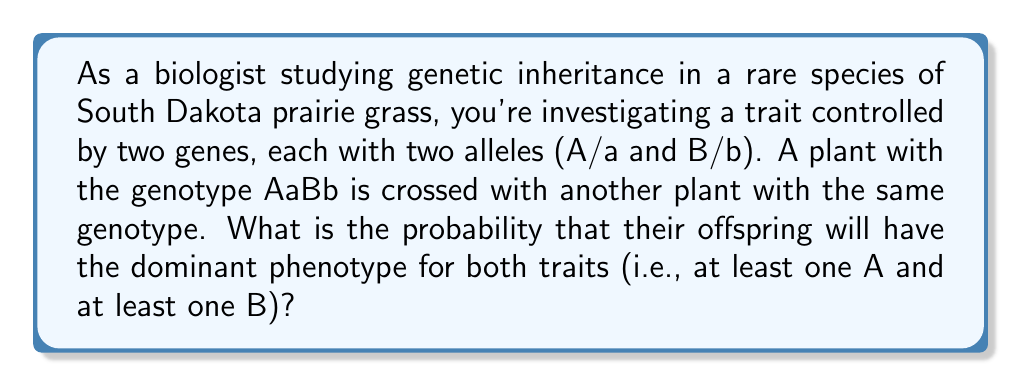Help me with this question. To solve this problem, we need to use the principles of Mendelian genetics and probability theory. Let's break it down step-by-step:

1. For each gene, we need to calculate the probability of having at least one dominant allele:

   For gene A:
   P(at least one A) = 1 - P(no A) = 1 - P(aa) = 1 - (1/4) = 3/4

   For gene B:
   P(at least one B) = 1 - P(no B) = 1 - P(bb) = 1 - (1/4) = 3/4

2. Since we need both conditions to be true (at least one A AND at least one B), we multiply these probabilities:

   $$P(\text{at least one A and at least one B}) = P(\text{at least one A}) \times P(\text{at least one B})$$

3. Substituting the values:

   $$P(\text{at least one A and at least one B}) = \frac{3}{4} \times \frac{3}{4} = \frac{9}{16}$$

This means that out of all possible offspring, 9/16 will have the dominant phenotype for both traits.
Answer: $\frac{9}{16}$ or $0.5625$ or $56.25\%$ 